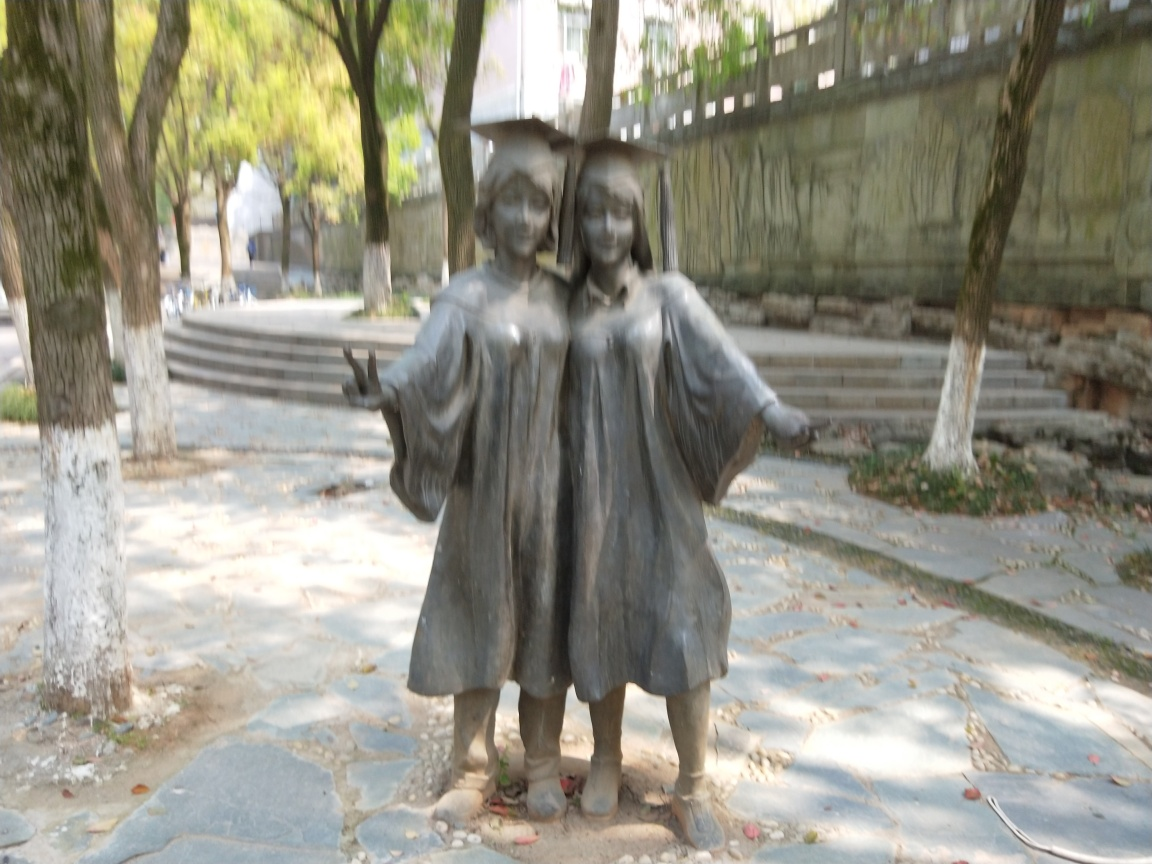Can you describe what the statue in the image represents? The statue features two figures, which seem to be interacting with each other in a friendly manner, possibly suggesting a theme of companionship or friendship. The style of the statue appears contemporary, with the figures dressed in modern attire. Without additional context, it's hard to determine the exact significance, but it might commemorate a local historical event, represent a cultural narrative, or simply be a public art installation aimed at enhancing the aesthetics of the area. 